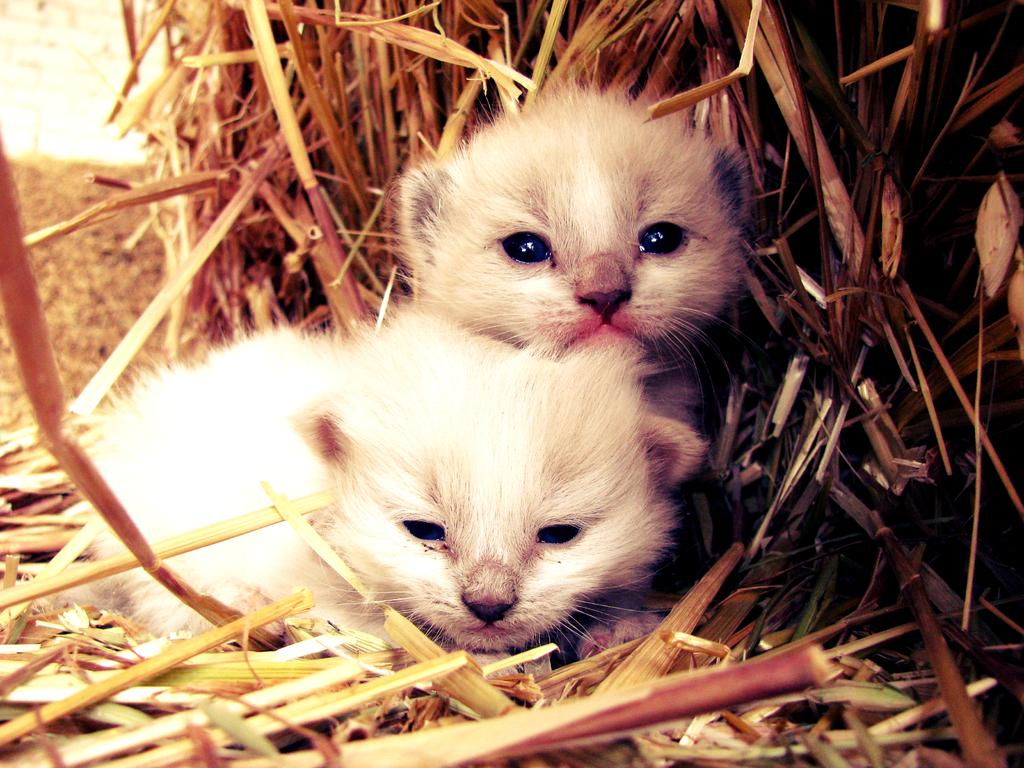What type of animals are in the image? There are kittens in the image. What color are the kittens? The kittens are white in color. What type of vegetation is visible in the image? There is dry grass visible in the image. What type of silk is being used to make the quince in the image? There is no silk or quince present in the image; it features white kittens and dry grass. 